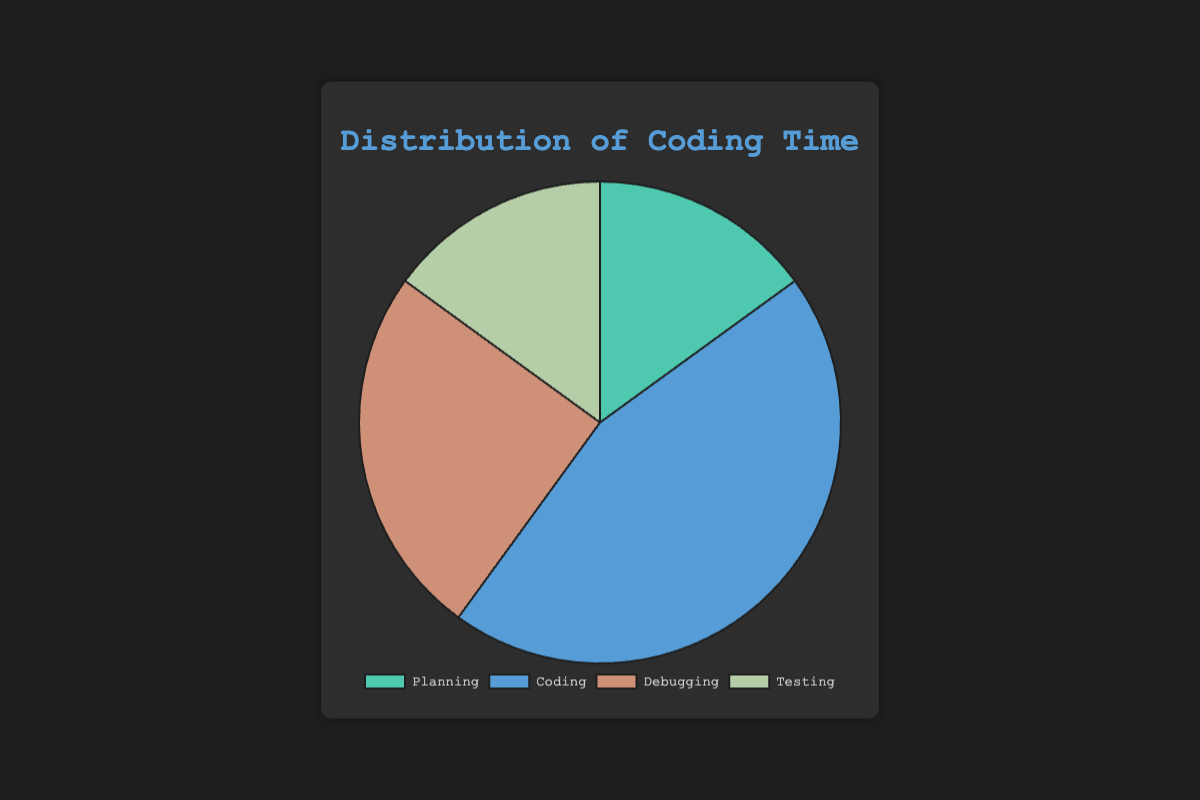Which stage takes up the majority of the coding time? By looking at the pie chart, we can compare the slices representing each stage. The largest slice represents Coding with 45%.
Answer: Coding Which two stages have an equal distribution of time? The pie chart shows that Planning and Testing both have slices representing 15% of the total time.
Answer: Planning and Testing How much time in total is spent on Planning and Testing combined? To find the total time spent on Planning and Testing, we add their percentages: 15% (Planning) + 15% (Testing) = 30%.
Answer: 30% Is more time spent on Debugging or on Planning? By comparing the slices, Debugging has a larger percentage (25%) than Planning (15%).
Answer: Debugging What is the difference in time spent between the stage with the most time and the stage with the least time? The stage with the most time is Coding at 45%, and the stages with the least time are Planning and Testing both at 15%. The difference is 45% - 15% = 30%.
Answer: 30% If an additional 10% of time were added to the Debugging stage, how much time would it take up in total? Initially, Debugging takes up 25%. Adding 10% results in 25% + 10% = 35%.
Answer: 35% What is the ratio of time spent on Coding to time spent on Testing? Coding takes up 45% and Testing takes up 15%. The ratio is 45% : 15% = 3:1.
Answer: 3:1 Which stage is represented by a green slice? Visual inspection of the pie chart shows that Planning is represented by a green slice.
Answer: Planning If you were to divide the time spent on Coding evenly between Debugging and Testing, how much time would each of these take then? Currently, Coding takes up 45%. Dividing this equally between Debugging and Testing adds 22.5% to each. Debugging would then take up 25% + 22.5% = 47.5%, and Testing would take up 15% + 22.5% = 37.5%.
Answer: Debugging: 47.5%, Testing: 37.5% Which stage has a slice represented by brown color? Visual inspection of the pie chart shows that Debugging is represented by a brown slice.
Answer: Debugging 